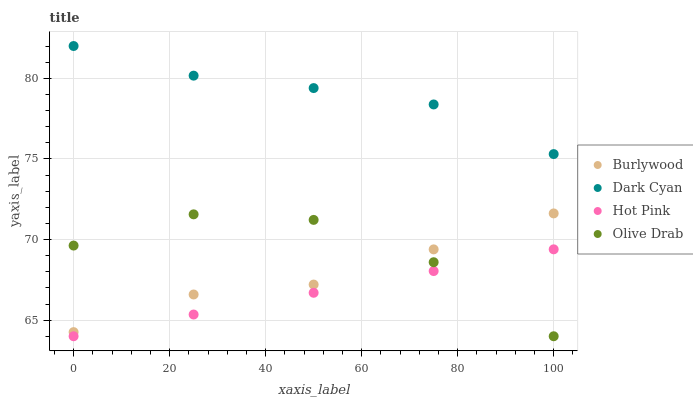Does Hot Pink have the minimum area under the curve?
Answer yes or no. Yes. Does Dark Cyan have the maximum area under the curve?
Answer yes or no. Yes. Does Dark Cyan have the minimum area under the curve?
Answer yes or no. No. Does Hot Pink have the maximum area under the curve?
Answer yes or no. No. Is Hot Pink the smoothest?
Answer yes or no. Yes. Is Olive Drab the roughest?
Answer yes or no. Yes. Is Dark Cyan the smoothest?
Answer yes or no. No. Is Dark Cyan the roughest?
Answer yes or no. No. Does Hot Pink have the lowest value?
Answer yes or no. Yes. Does Dark Cyan have the lowest value?
Answer yes or no. No. Does Dark Cyan have the highest value?
Answer yes or no. Yes. Does Hot Pink have the highest value?
Answer yes or no. No. Is Hot Pink less than Dark Cyan?
Answer yes or no. Yes. Is Dark Cyan greater than Burlywood?
Answer yes or no. Yes. Does Hot Pink intersect Olive Drab?
Answer yes or no. Yes. Is Hot Pink less than Olive Drab?
Answer yes or no. No. Is Hot Pink greater than Olive Drab?
Answer yes or no. No. Does Hot Pink intersect Dark Cyan?
Answer yes or no. No. 